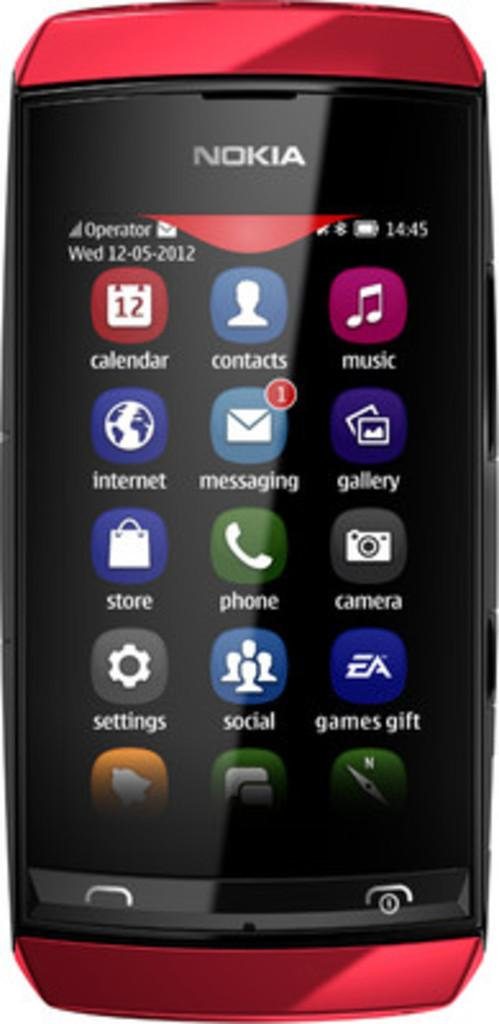<image>
Offer a succinct explanation of the picture presented. An older model of a Nokia cell phone with the home page full of app icons and the phone is red. 